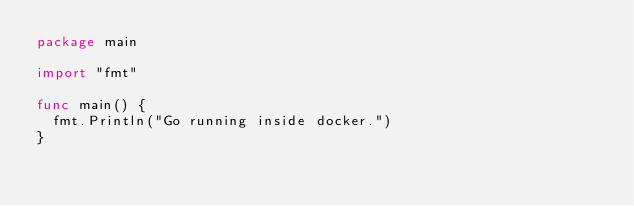Convert code to text. <code><loc_0><loc_0><loc_500><loc_500><_Go_>package main

import "fmt"

func main() {
  fmt.Println("Go running inside docker.")
}</code> 